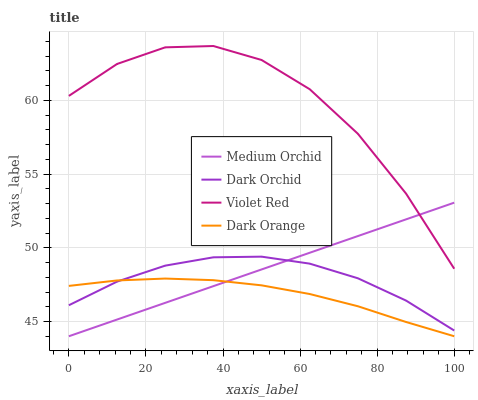Does Dark Orange have the minimum area under the curve?
Answer yes or no. Yes. Does Violet Red have the maximum area under the curve?
Answer yes or no. Yes. Does Medium Orchid have the minimum area under the curve?
Answer yes or no. No. Does Medium Orchid have the maximum area under the curve?
Answer yes or no. No. Is Medium Orchid the smoothest?
Answer yes or no. Yes. Is Violet Red the roughest?
Answer yes or no. Yes. Is Violet Red the smoothest?
Answer yes or no. No. Is Medium Orchid the roughest?
Answer yes or no. No. Does Dark Orange have the lowest value?
Answer yes or no. Yes. Does Violet Red have the lowest value?
Answer yes or no. No. Does Violet Red have the highest value?
Answer yes or no. Yes. Does Medium Orchid have the highest value?
Answer yes or no. No. Is Dark Orange less than Violet Red?
Answer yes or no. Yes. Is Violet Red greater than Dark Orange?
Answer yes or no. Yes. Does Medium Orchid intersect Dark Orchid?
Answer yes or no. Yes. Is Medium Orchid less than Dark Orchid?
Answer yes or no. No. Is Medium Orchid greater than Dark Orchid?
Answer yes or no. No. Does Dark Orange intersect Violet Red?
Answer yes or no. No. 